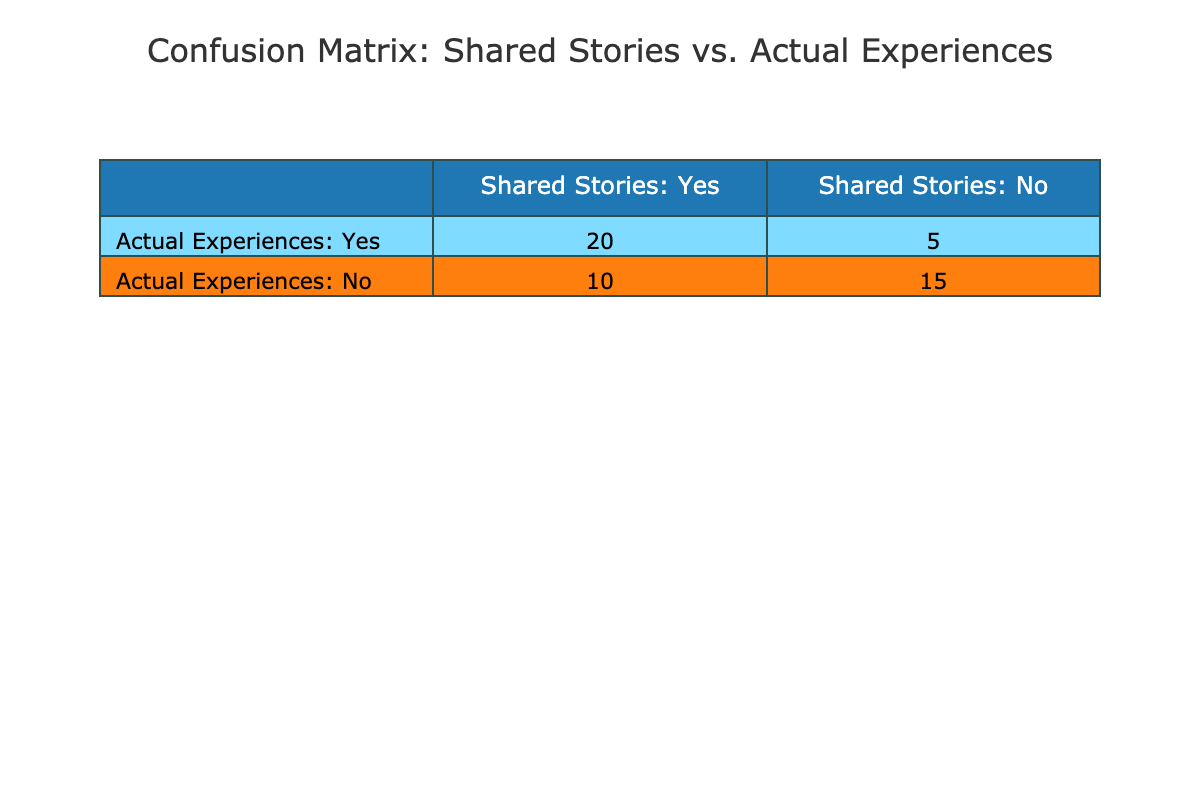What are the True Positives in the table? The True Positives are the values under "Shared Stories: Yes" and "Actual Experiences: Yes". According to the table, this value is 20.
Answer: 20 What is the sum of True Positives and True Negatives? The True Positives are 20, and the True Negatives are 15. Adding these two values, we have 20 + 15 = 35.
Answer: 35 How many drivers did not share their stories (False Negatives)? The False Negatives are the drivers who had actual experiences but did not share their stories. According to the table, this value is 10.
Answer: 10 Is it true that more drivers shared their stories than those who did not? To find out, we compare the True Positives (20) and False Positives (5) to calculate total shared stories: 20 + 5 = 25. For total non-shared stories, we see False Negatives (10) and True Negatives (15): 10 + 15 = 25. They are equal; thus, the statement is false.
Answer: No What is the difference between the number of True Positives and False Negatives? The True Positives are 20, and the False Negatives are 10. The difference is calculated by subtracting False Negatives from True Positives: 20 - 10 = 10.
Answer: 10 If we consider all shared stories (True Positives and False Positives), what percentage of these are True Positives? The total number of shared stories is found by adding True Positives (20) and False Positives (5): 20 + 5 = 25. The percentage of True Positives is then calculated as (True Positives / Total Shared Stories) * 100: (20 / 25) * 100 = 80%.
Answer: 80% How many actual experiences went unshared by drivers? Actual experiences are represented by False Negatives (10) and True Negatives (15). Therefore, the total unshared actual experiences are calculated as False Negatives: 10.
Answer: 10 What is the ratio of True Negatives to False Positives? True Negatives are 15, and False Positives are 5. The ratio is calculated as 15:5, which simplifies to 3:1.
Answer: 3:1 